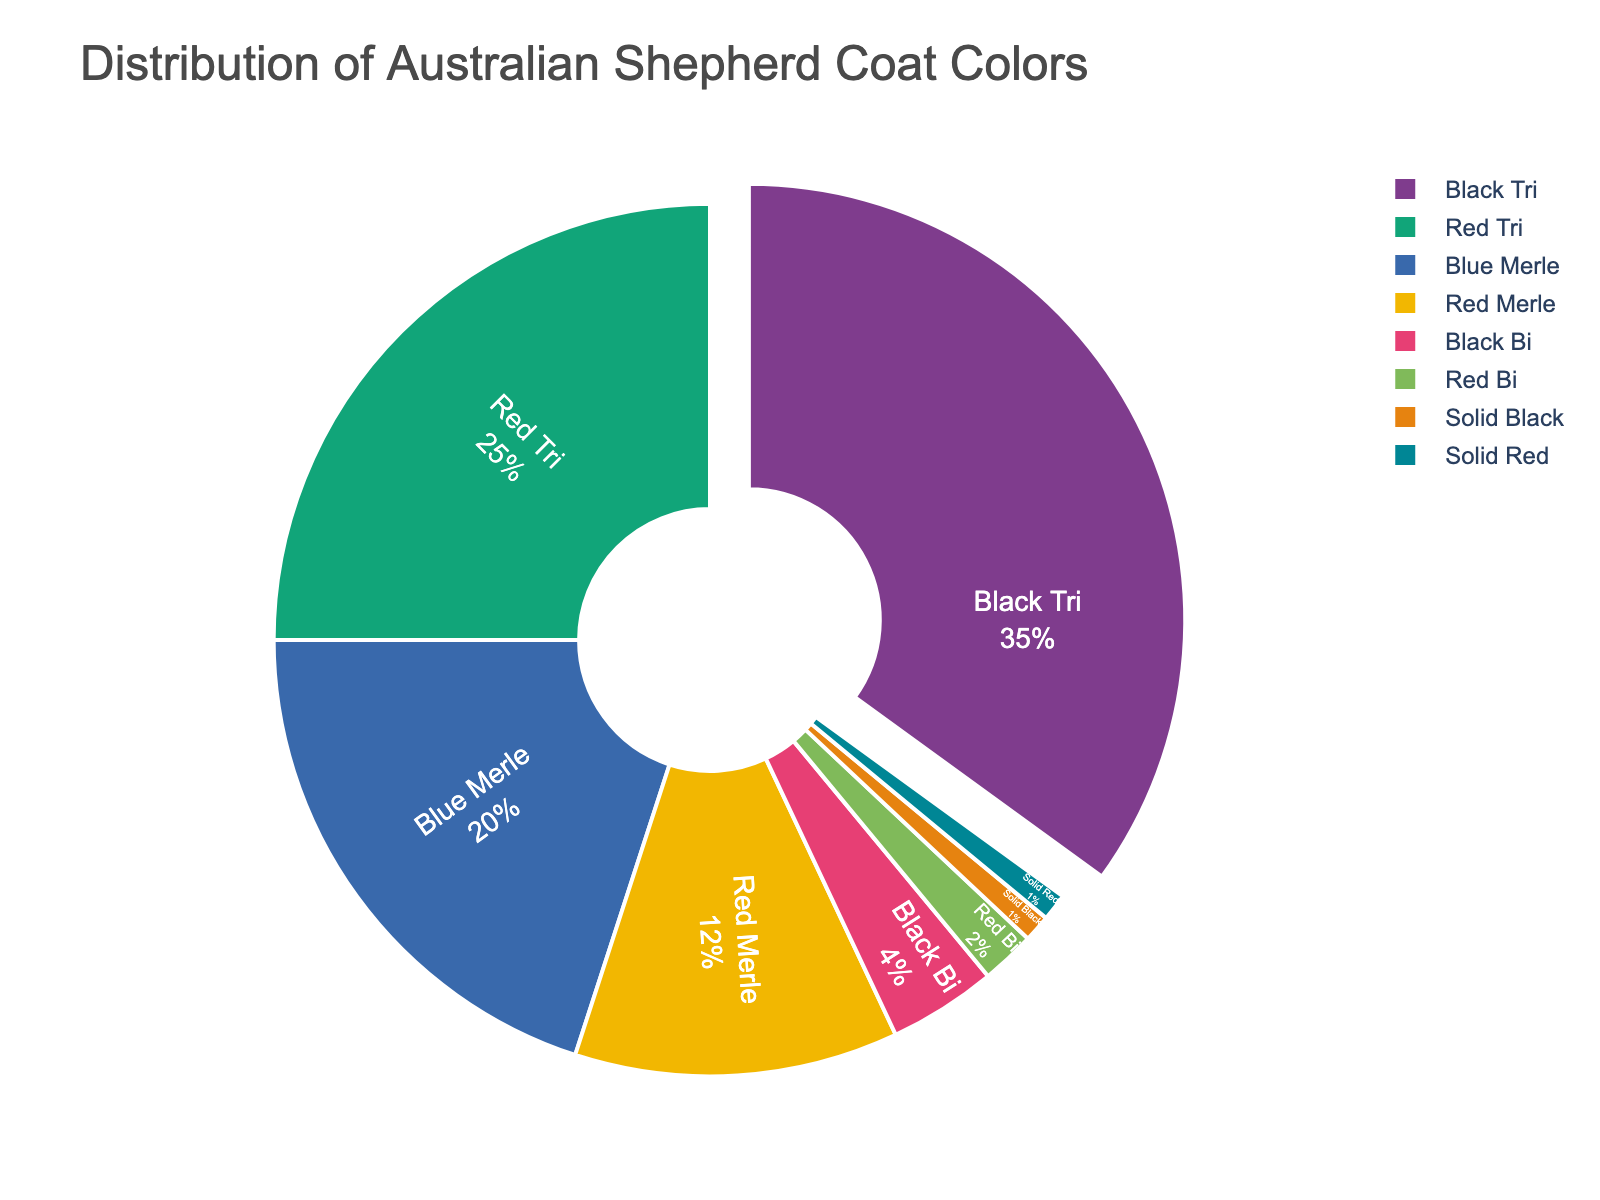What's the most common coat color among registered Australian Shepherds? The pie chart shows the distribution of coat colors. The largest segment represents the most common coat color.
Answer: Black Tri Which two coat colors have a combined percentage greater than 50%? Adding the percentages, Black Tri (35%) and Red Tri (25%) sum up to 60%, which is greater than 50%.
Answer: Black Tri and Red Tri Are there more Blue Merles or Red Merles? Comparing the pie chart segments for Blue Merle (20%) and Red Merle (12%) shows that Blue Merle has a larger percentage.
Answer: Blue Merle Which coat color makes up only 1% of the registered dogs? The pie chart indicates that both Solid Black and Solid Red each make up 1%.
Answer: Solid Black and Solid Red What is the total percentage of Solid-colored Australian Shepherds? The pie chart shows Solid Black (1%) and Solid Red (1%). Summing these gives 2%.
Answer: 2% What's the percentage difference between Black Tri and Red Tri coats? The difference is calculated as 35% (Black Tri) - 25% (Red Tri) = 10%.
Answer: 10% Is the percentage of dogs with a Black Bi coat greater than those with a Red Bi coat? The pie chart indicates Black Bi (4%) and Red Bi (2%). Comparing these percentages shows Black Bi is greater.
Answer: Yes What's the total percentage for all merle coat colors combined? Summing Blue Merle (20%) and Red Merle (12%) results in 32%.
Answer: 32% How does the size of the smallest segment compare to the largest segment in the pie chart? The smallest segments are Solid Black (1%) and Solid Red (1%), and the largest is Black Tri (35%). The difference is 34%.
Answer: 34% If you combine the Black Tri and Red Tri percentages, what fraction of the total do they represent? Adding Black Tri (35%) and Red Tri (25%) gives 60%. Since the total is 100%, they represent 60/100 or 3/5 of the total.
Answer: 3/5 